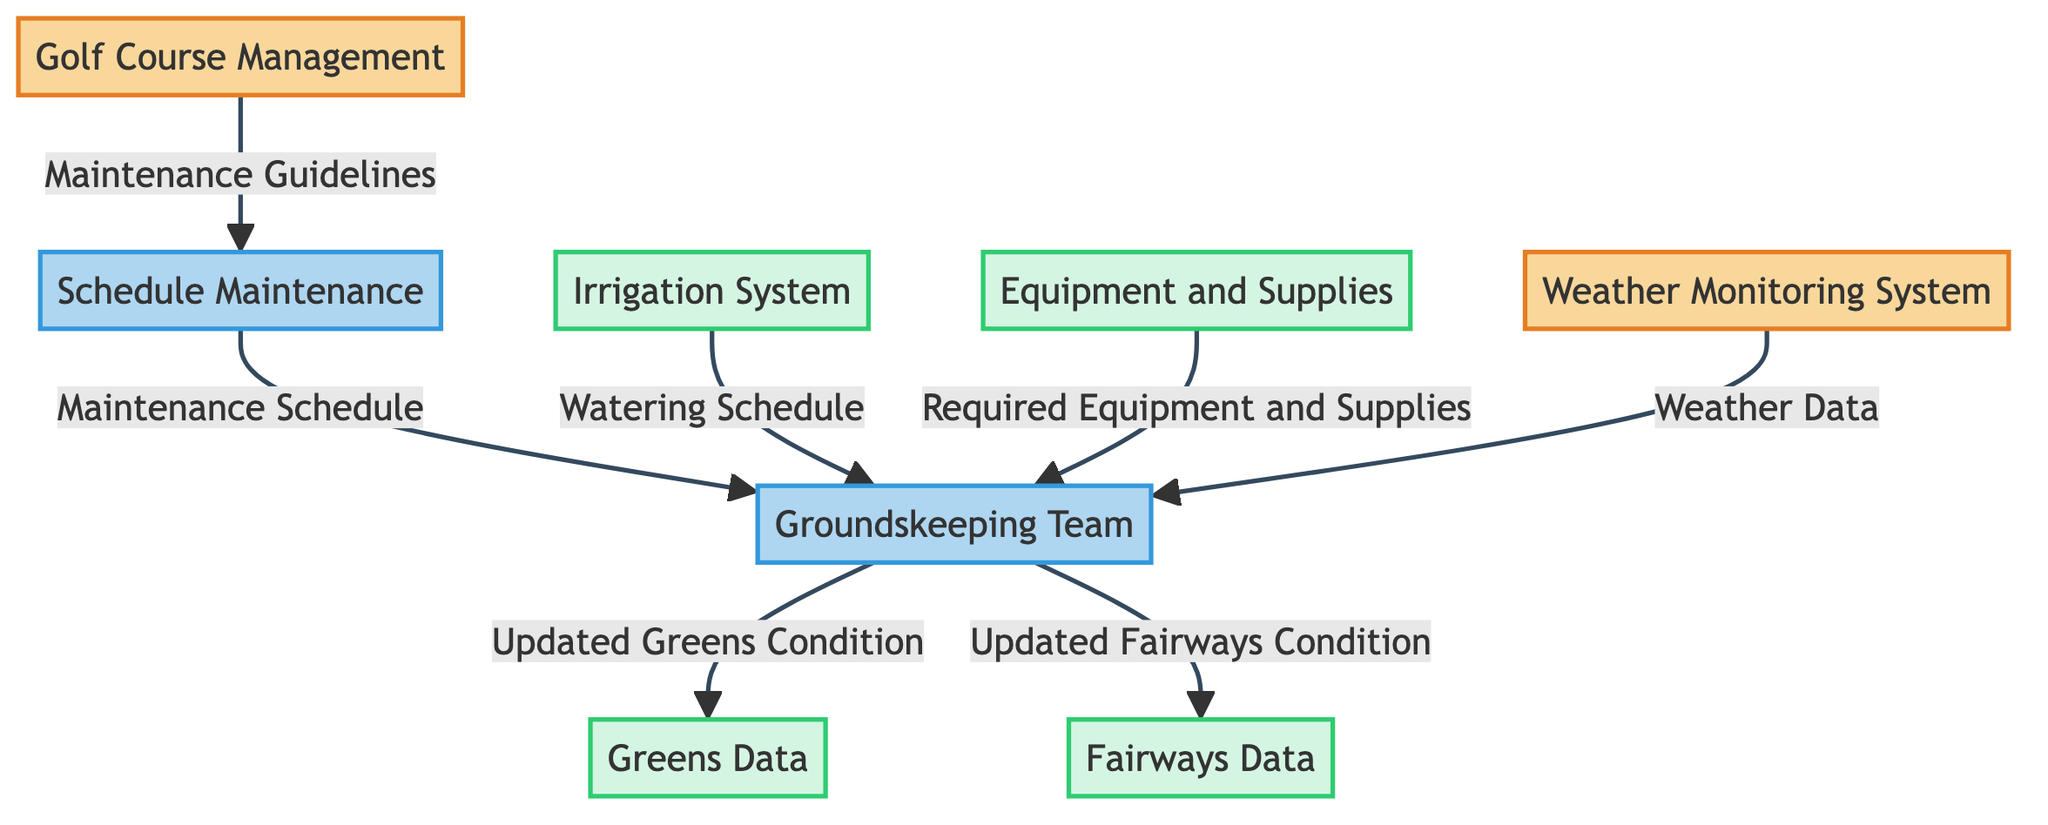What external entities are involved in the diagram? The diagram shows two external entities: Golf Course Management and Weather Monitoring System. These entities provide critical information to the processes within the diagram.
Answer: Golf Course Management, Weather Monitoring System How many data stores are present in the diagram? There are four data stores represented in the diagram: Irrigation System, Equipment and Supplies, Greens Data, and Fairways Data. These stores maintain data that is used by the processes.
Answer: Four What data flows from the Schedule Maintenance to the Groundskeeping Team? According to the diagram, the data flow from Schedule Maintenance to the Groundskeeping Team is labeled as Maintenance Schedule, indicating the plans for maintenance activities.
Answer: Maintenance Schedule Which process relies on the Weather Monitoring System? The Groundskeeping Team relies on the Weather Monitoring System for real-time Weather Data, which helps in planning the maintenance tasks more effectively.
Answer: Groundskeeping Team What is the purpose of the Irrigation System according to the diagram? The Irrigation System serves the purpose of providing a Watering Schedule to the Groundskeeping Team, ensuring proper irrigation of the greens and fairways.
Answer: Watering Schedule What information does the Groundskeeping Team provide to the Greens Data? The Groundskeeping Team updates the Greens Data with the current conditions under the label Updated Greens Condition, documenting the health and status of the greens.
Answer: Updated Greens Condition Which data store receives updates from the Groundskeeping Team? The Fairways Data receives updates from the Groundskeeping Team, specifically the updated condition that reflects the current state of the fairways.
Answer: Fairways Data What does the Groundskeeping Team receive from the Equipment and Supplies data store? The Groundskeeping Team obtains the Required Equipment and Supplies from the Equipment and Supplies data store, which ensures they have what is necessary for maintenance.
Answer: Required Equipment and Supplies How does Golf Course Management influence the Schedule Maintenance process? Golf Course Management influences the Schedule Maintenance process by providing Maintenance Guidelines that inform the scheduling and planning of maintenance activities.
Answer: Maintenance Guidelines 